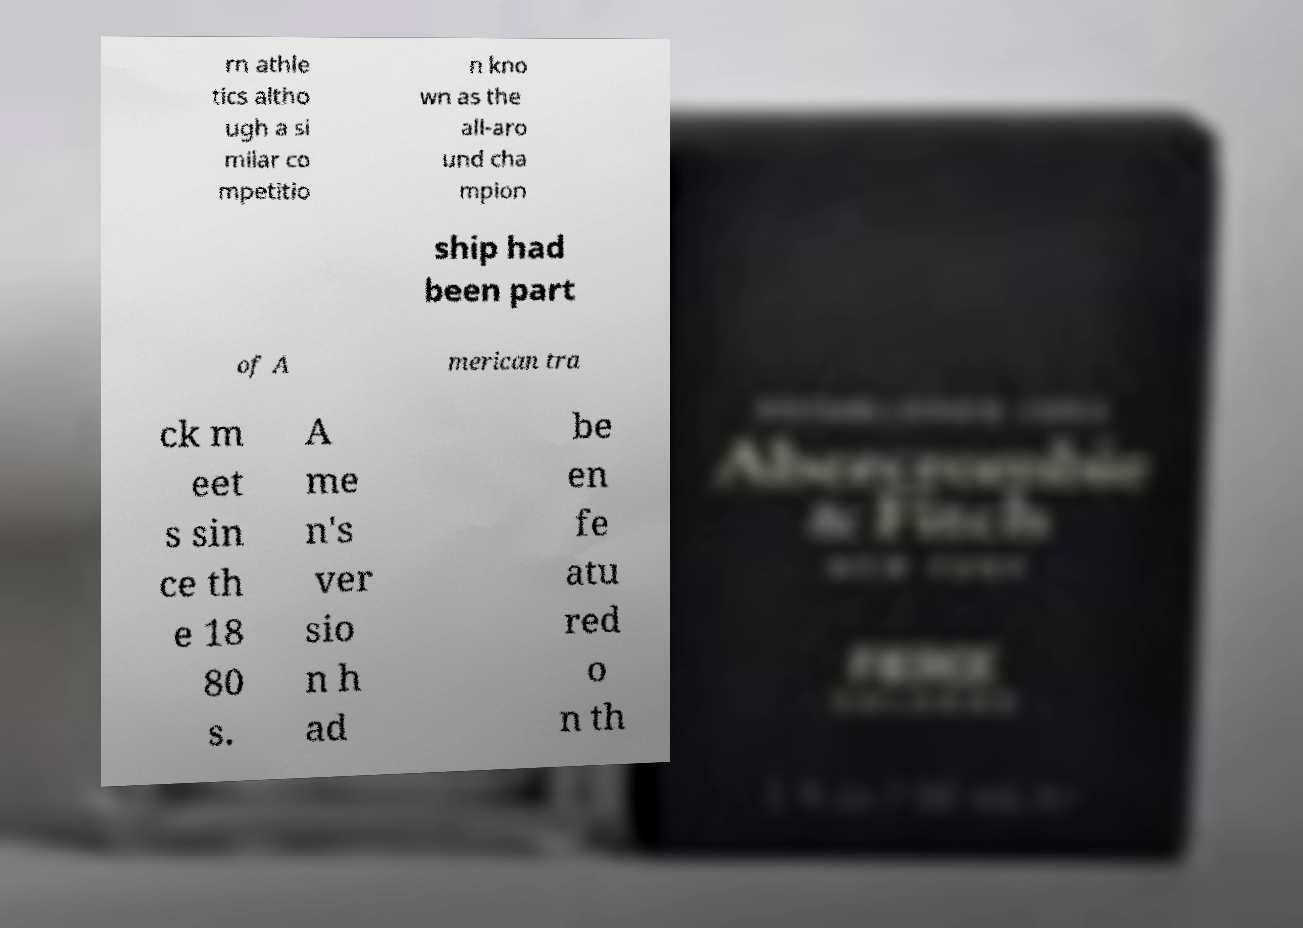Is there any indication of the document's origin or its purpose based on the visible text? Based on the visible text, the document might be related to the historical documentation of athletic competitions, possibly summarizing the key events in American track and field sports. The purpose seems educational or archival, highlighting significant milestones or champions. 